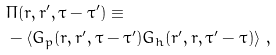<formula> <loc_0><loc_0><loc_500><loc_500>& \Pi ( { r } , { r } ^ { \prime } , \tau - \tau ^ { \prime } ) \equiv \\ & - \langle G _ { p } ( { r } , { r } ^ { \prime } , \tau - \tau ^ { \prime } ) G _ { h } ( { r } ^ { \prime } , { r } , \tau ^ { \prime } - \tau ) \rangle \ ,</formula> 